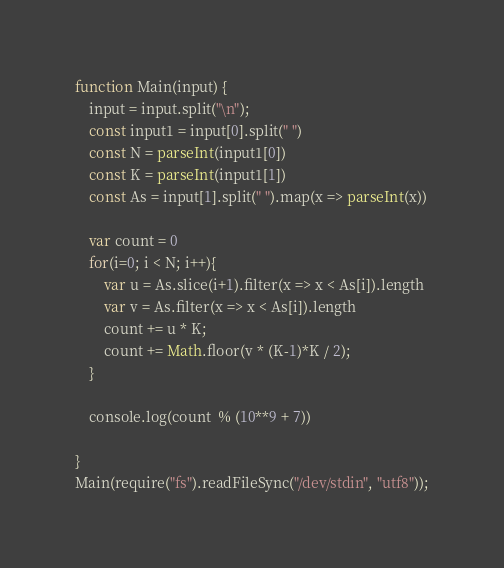Convert code to text. <code><loc_0><loc_0><loc_500><loc_500><_JavaScript_>function Main(input) {
	input = input.split("\n");
	const input1 = input[0].split(" ")
	const N = parseInt(input1[0])
	const K = parseInt(input1[1])
	const As = input[1].split(" ").map(x => parseInt(x))

	var count = 0
	for(i=0; i < N; i++){
		var u = As.slice(i+1).filter(x => x < As[i]).length
		var v = As.filter(x => x < As[i]).length
		count += u * K;
		count += Math.floor(v * (K-1)*K / 2);
	}

	console.log(count  % (10**9 + 7))

}
Main(require("fs").readFileSync("/dev/stdin", "utf8"));</code> 